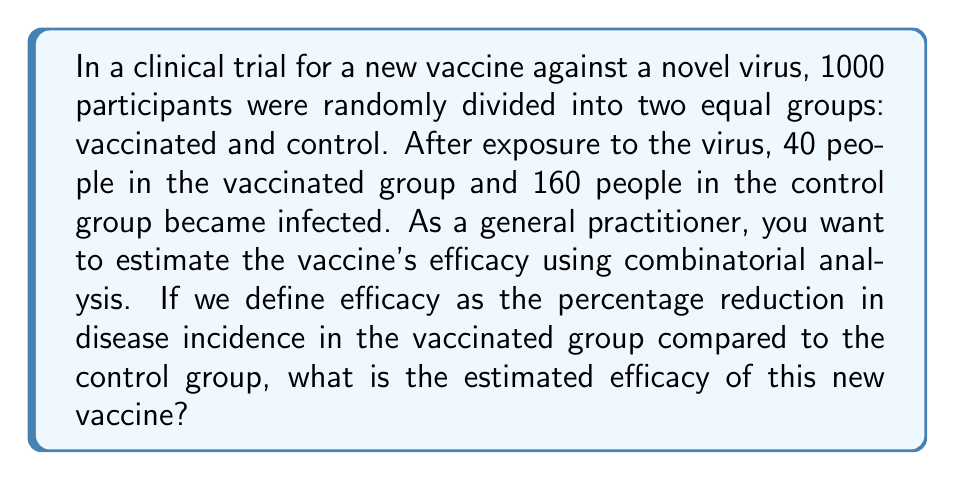Can you answer this question? To estimate the vaccine's efficacy using combinatorial analysis, we need to follow these steps:

1. Calculate the incidence rate in each group:
   - Vaccinated group: $40 / 500 = 0.08$ or $8\%$
   - Control group: $160 / 500 = 0.32$ or $32\%$

2. The vaccine efficacy (VE) is defined as the percentage reduction in disease incidence in the vaccinated group compared to the control group. We can calculate this using the following formula:

   $$ VE = \frac{I_c - I_v}{I_c} \times 100\% $$

   Where $I_c$ is the incidence in the control group and $I_v$ is the incidence in the vaccinated group.

3. Substituting the values:

   $$ VE = \frac{0.32 - 0.08}{0.32} \times 100\% $$

4. Simplifying:
   
   $$ VE = \frac{0.24}{0.32} \times 100\% = 0.75 \times 100\% = 75\% $$

Therefore, the estimated efficacy of the new vaccine is 75%.

This means that the vaccine reduces the risk of infection by 75% compared to not being vaccinated. As a general practitioner, this information is crucial for recommending the vaccine to patients and explaining its potential benefits.
Answer: The estimated efficacy of the new vaccine is 75%. 